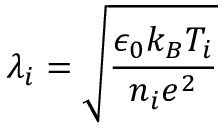Convert formula to latex. <formula><loc_0><loc_0><loc_500><loc_500>\lambda _ { i } = \sqrt { \frac { \epsilon _ { 0 } k _ { B } T _ { i } } { n _ { i } e ^ { 2 } } }</formula> 